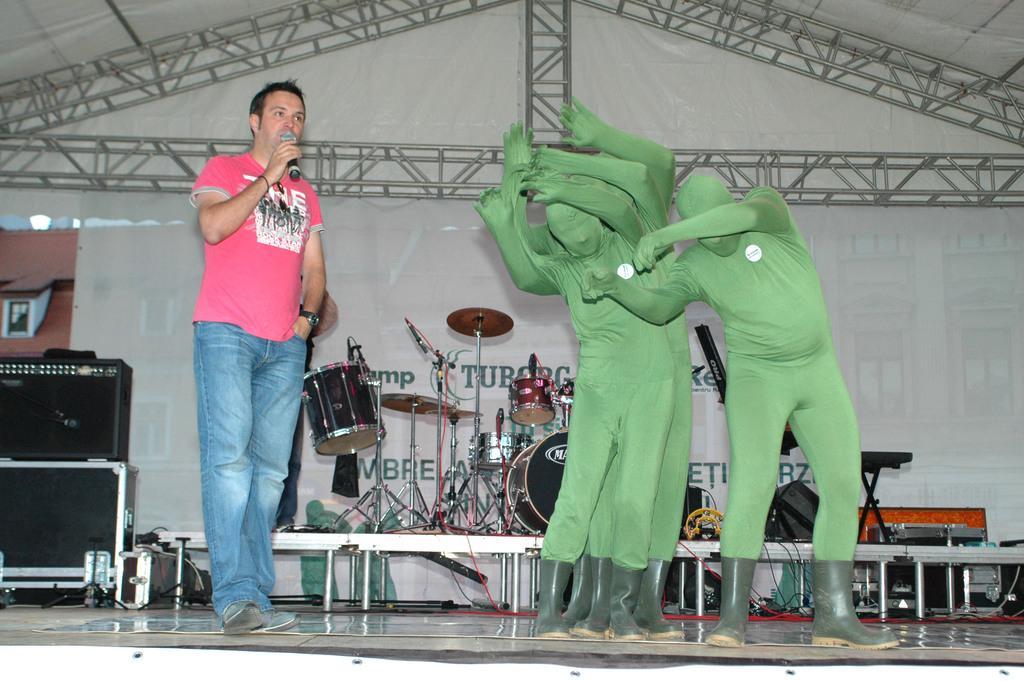In one or two sentences, can you explain what this image depicts? This picture shows a few people standing on the dais and we see a man standing and holding a microphone in his hand and speaking and we see few people dancing they wore green color masks and we see drums and couple of musical instruments on the table and we see speakers on the side. 